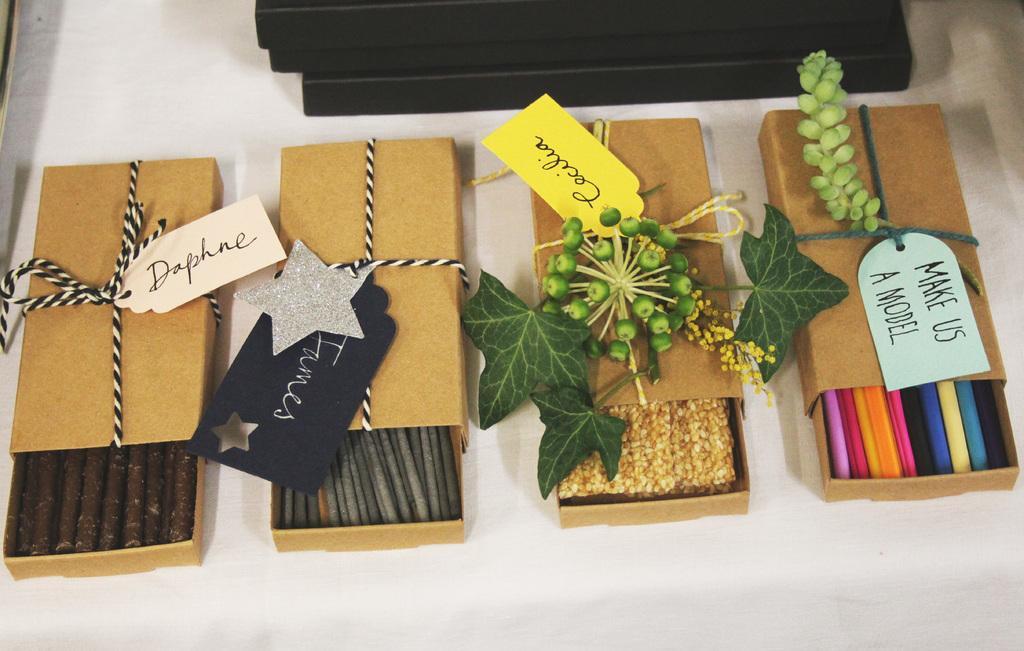Could you give a brief overview of what you see in this image? In this image on a table there are four boxes. On it there are leaves. On the box there are tags. Inside the box some food items are there. In the background few other boxes are there. 